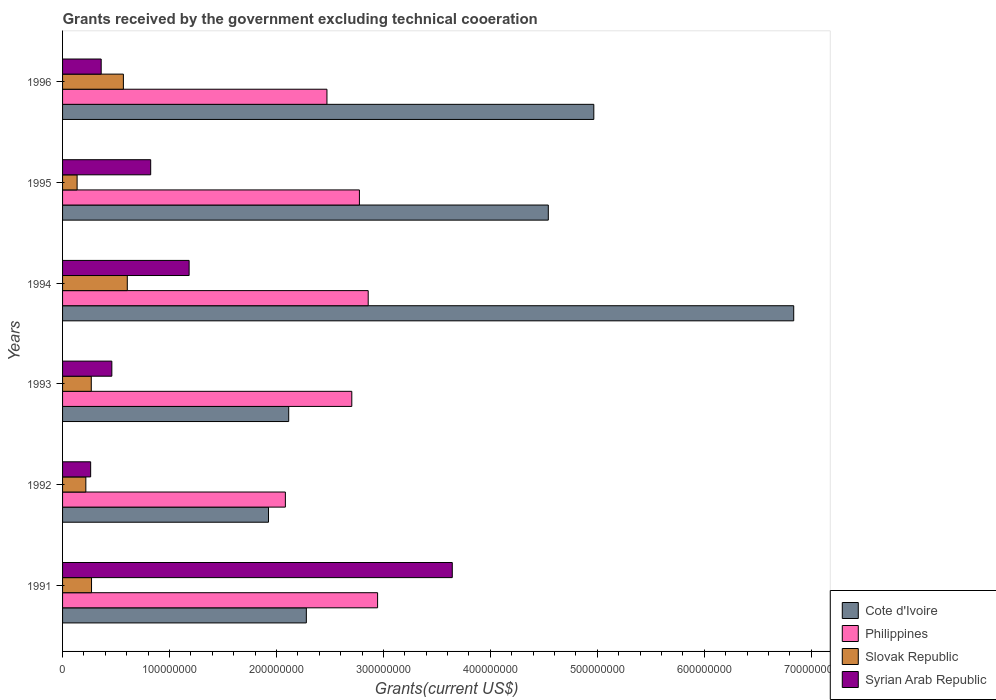How many different coloured bars are there?
Make the answer very short. 4. Are the number of bars per tick equal to the number of legend labels?
Offer a very short reply. Yes. Are the number of bars on each tick of the Y-axis equal?
Provide a succinct answer. Yes. How many bars are there on the 3rd tick from the bottom?
Your response must be concise. 4. What is the total grants received by the government in Syrian Arab Republic in 1992?
Provide a short and direct response. 2.63e+07. Across all years, what is the maximum total grants received by the government in Philippines?
Offer a terse response. 2.95e+08. Across all years, what is the minimum total grants received by the government in Slovak Republic?
Your answer should be very brief. 1.36e+07. In which year was the total grants received by the government in Philippines minimum?
Give a very brief answer. 1992. What is the total total grants received by the government in Syrian Arab Republic in the graph?
Offer a terse response. 6.74e+08. What is the difference between the total grants received by the government in Philippines in 1994 and that in 1996?
Your answer should be compact. 3.86e+07. What is the difference between the total grants received by the government in Cote d'Ivoire in 1994 and the total grants received by the government in Philippines in 1991?
Offer a very short reply. 3.89e+08. What is the average total grants received by the government in Cote d'Ivoire per year?
Keep it short and to the point. 3.78e+08. In the year 1991, what is the difference between the total grants received by the government in Cote d'Ivoire and total grants received by the government in Slovak Republic?
Make the answer very short. 2.01e+08. What is the ratio of the total grants received by the government in Philippines in 1993 to that in 1996?
Your answer should be compact. 1.09. What is the difference between the highest and the second highest total grants received by the government in Syrian Arab Republic?
Your answer should be compact. 2.46e+08. What is the difference between the highest and the lowest total grants received by the government in Syrian Arab Republic?
Keep it short and to the point. 3.38e+08. In how many years, is the total grants received by the government in Syrian Arab Republic greater than the average total grants received by the government in Syrian Arab Republic taken over all years?
Offer a very short reply. 2. What does the 3rd bar from the top in 1995 represents?
Make the answer very short. Philippines. What does the 2nd bar from the bottom in 1996 represents?
Make the answer very short. Philippines. How many bars are there?
Ensure brevity in your answer.  24. Does the graph contain grids?
Ensure brevity in your answer.  No. Where does the legend appear in the graph?
Provide a short and direct response. Bottom right. What is the title of the graph?
Offer a terse response. Grants received by the government excluding technical cooeration. What is the label or title of the X-axis?
Your answer should be compact. Grants(current US$). What is the Grants(current US$) of Cote d'Ivoire in 1991?
Provide a short and direct response. 2.28e+08. What is the Grants(current US$) in Philippines in 1991?
Your answer should be compact. 2.95e+08. What is the Grants(current US$) of Slovak Republic in 1991?
Make the answer very short. 2.71e+07. What is the Grants(current US$) in Syrian Arab Republic in 1991?
Keep it short and to the point. 3.64e+08. What is the Grants(current US$) in Cote d'Ivoire in 1992?
Make the answer very short. 1.93e+08. What is the Grants(current US$) of Philippines in 1992?
Offer a very short reply. 2.08e+08. What is the Grants(current US$) of Slovak Republic in 1992?
Offer a terse response. 2.18e+07. What is the Grants(current US$) in Syrian Arab Republic in 1992?
Offer a very short reply. 2.63e+07. What is the Grants(current US$) in Cote d'Ivoire in 1993?
Make the answer very short. 2.11e+08. What is the Grants(current US$) of Philippines in 1993?
Provide a short and direct response. 2.70e+08. What is the Grants(current US$) of Slovak Republic in 1993?
Offer a very short reply. 2.68e+07. What is the Grants(current US$) of Syrian Arab Republic in 1993?
Give a very brief answer. 4.61e+07. What is the Grants(current US$) of Cote d'Ivoire in 1994?
Offer a terse response. 6.84e+08. What is the Grants(current US$) of Philippines in 1994?
Provide a short and direct response. 2.86e+08. What is the Grants(current US$) in Slovak Republic in 1994?
Keep it short and to the point. 6.05e+07. What is the Grants(current US$) of Syrian Arab Republic in 1994?
Offer a terse response. 1.18e+08. What is the Grants(current US$) of Cote d'Ivoire in 1995?
Give a very brief answer. 4.54e+08. What is the Grants(current US$) in Philippines in 1995?
Offer a very short reply. 2.78e+08. What is the Grants(current US$) of Slovak Republic in 1995?
Provide a succinct answer. 1.36e+07. What is the Grants(current US$) of Syrian Arab Republic in 1995?
Keep it short and to the point. 8.24e+07. What is the Grants(current US$) of Cote d'Ivoire in 1996?
Ensure brevity in your answer.  4.97e+08. What is the Grants(current US$) of Philippines in 1996?
Provide a succinct answer. 2.47e+08. What is the Grants(current US$) in Slovak Republic in 1996?
Keep it short and to the point. 5.69e+07. What is the Grants(current US$) in Syrian Arab Republic in 1996?
Offer a very short reply. 3.61e+07. Across all years, what is the maximum Grants(current US$) in Cote d'Ivoire?
Your response must be concise. 6.84e+08. Across all years, what is the maximum Grants(current US$) of Philippines?
Make the answer very short. 2.95e+08. Across all years, what is the maximum Grants(current US$) of Slovak Republic?
Your answer should be very brief. 6.05e+07. Across all years, what is the maximum Grants(current US$) of Syrian Arab Republic?
Your response must be concise. 3.64e+08. Across all years, what is the minimum Grants(current US$) of Cote d'Ivoire?
Ensure brevity in your answer.  1.93e+08. Across all years, what is the minimum Grants(current US$) of Philippines?
Ensure brevity in your answer.  2.08e+08. Across all years, what is the minimum Grants(current US$) of Slovak Republic?
Give a very brief answer. 1.36e+07. Across all years, what is the minimum Grants(current US$) of Syrian Arab Republic?
Provide a short and direct response. 2.63e+07. What is the total Grants(current US$) in Cote d'Ivoire in the graph?
Your response must be concise. 2.27e+09. What is the total Grants(current US$) of Philippines in the graph?
Provide a succinct answer. 1.58e+09. What is the total Grants(current US$) of Slovak Republic in the graph?
Provide a succinct answer. 2.07e+08. What is the total Grants(current US$) in Syrian Arab Republic in the graph?
Give a very brief answer. 6.74e+08. What is the difference between the Grants(current US$) in Cote d'Ivoire in 1991 and that in 1992?
Your response must be concise. 3.54e+07. What is the difference between the Grants(current US$) in Philippines in 1991 and that in 1992?
Keep it short and to the point. 8.62e+07. What is the difference between the Grants(current US$) in Slovak Republic in 1991 and that in 1992?
Provide a succinct answer. 5.33e+06. What is the difference between the Grants(current US$) of Syrian Arab Republic in 1991 and that in 1992?
Provide a succinct answer. 3.38e+08. What is the difference between the Grants(current US$) of Cote d'Ivoire in 1991 and that in 1993?
Offer a terse response. 1.65e+07. What is the difference between the Grants(current US$) of Philippines in 1991 and that in 1993?
Provide a short and direct response. 2.41e+07. What is the difference between the Grants(current US$) of Slovak Republic in 1991 and that in 1993?
Offer a very short reply. 2.40e+05. What is the difference between the Grants(current US$) in Syrian Arab Republic in 1991 and that in 1993?
Make the answer very short. 3.18e+08. What is the difference between the Grants(current US$) in Cote d'Ivoire in 1991 and that in 1994?
Keep it short and to the point. -4.56e+08. What is the difference between the Grants(current US$) in Philippines in 1991 and that in 1994?
Your response must be concise. 8.77e+06. What is the difference between the Grants(current US$) in Slovak Republic in 1991 and that in 1994?
Ensure brevity in your answer.  -3.34e+07. What is the difference between the Grants(current US$) in Syrian Arab Republic in 1991 and that in 1994?
Make the answer very short. 2.46e+08. What is the difference between the Grants(current US$) of Cote d'Ivoire in 1991 and that in 1995?
Keep it short and to the point. -2.26e+08. What is the difference between the Grants(current US$) in Philippines in 1991 and that in 1995?
Provide a succinct answer. 1.70e+07. What is the difference between the Grants(current US$) in Slovak Republic in 1991 and that in 1995?
Offer a terse response. 1.35e+07. What is the difference between the Grants(current US$) in Syrian Arab Republic in 1991 and that in 1995?
Give a very brief answer. 2.82e+08. What is the difference between the Grants(current US$) in Cote d'Ivoire in 1991 and that in 1996?
Your answer should be compact. -2.69e+08. What is the difference between the Grants(current US$) of Philippines in 1991 and that in 1996?
Provide a short and direct response. 4.74e+07. What is the difference between the Grants(current US$) of Slovak Republic in 1991 and that in 1996?
Your answer should be very brief. -2.98e+07. What is the difference between the Grants(current US$) in Syrian Arab Republic in 1991 and that in 1996?
Ensure brevity in your answer.  3.28e+08. What is the difference between the Grants(current US$) of Cote d'Ivoire in 1992 and that in 1993?
Offer a terse response. -1.89e+07. What is the difference between the Grants(current US$) of Philippines in 1992 and that in 1993?
Provide a short and direct response. -6.21e+07. What is the difference between the Grants(current US$) of Slovak Republic in 1992 and that in 1993?
Your answer should be very brief. -5.09e+06. What is the difference between the Grants(current US$) of Syrian Arab Republic in 1992 and that in 1993?
Your answer should be compact. -1.98e+07. What is the difference between the Grants(current US$) of Cote d'Ivoire in 1992 and that in 1994?
Ensure brevity in your answer.  -4.91e+08. What is the difference between the Grants(current US$) in Philippines in 1992 and that in 1994?
Offer a terse response. -7.74e+07. What is the difference between the Grants(current US$) of Slovak Republic in 1992 and that in 1994?
Offer a very short reply. -3.88e+07. What is the difference between the Grants(current US$) in Syrian Arab Republic in 1992 and that in 1994?
Keep it short and to the point. -9.21e+07. What is the difference between the Grants(current US$) of Cote d'Ivoire in 1992 and that in 1995?
Provide a short and direct response. -2.62e+08. What is the difference between the Grants(current US$) in Philippines in 1992 and that in 1995?
Provide a succinct answer. -6.92e+07. What is the difference between the Grants(current US$) of Slovak Republic in 1992 and that in 1995?
Your answer should be very brief. 8.16e+06. What is the difference between the Grants(current US$) in Syrian Arab Republic in 1992 and that in 1995?
Give a very brief answer. -5.61e+07. What is the difference between the Grants(current US$) of Cote d'Ivoire in 1992 and that in 1996?
Make the answer very short. -3.04e+08. What is the difference between the Grants(current US$) in Philippines in 1992 and that in 1996?
Your answer should be very brief. -3.89e+07. What is the difference between the Grants(current US$) of Slovak Republic in 1992 and that in 1996?
Offer a very short reply. -3.51e+07. What is the difference between the Grants(current US$) in Syrian Arab Republic in 1992 and that in 1996?
Give a very brief answer. -9.85e+06. What is the difference between the Grants(current US$) of Cote d'Ivoire in 1993 and that in 1994?
Your response must be concise. -4.72e+08. What is the difference between the Grants(current US$) of Philippines in 1993 and that in 1994?
Offer a terse response. -1.54e+07. What is the difference between the Grants(current US$) in Slovak Republic in 1993 and that in 1994?
Keep it short and to the point. -3.37e+07. What is the difference between the Grants(current US$) of Syrian Arab Republic in 1993 and that in 1994?
Keep it short and to the point. -7.23e+07. What is the difference between the Grants(current US$) of Cote d'Ivoire in 1993 and that in 1995?
Keep it short and to the point. -2.43e+08. What is the difference between the Grants(current US$) in Philippines in 1993 and that in 1995?
Offer a terse response. -7.13e+06. What is the difference between the Grants(current US$) in Slovak Republic in 1993 and that in 1995?
Your answer should be compact. 1.32e+07. What is the difference between the Grants(current US$) of Syrian Arab Republic in 1993 and that in 1995?
Give a very brief answer. -3.63e+07. What is the difference between the Grants(current US$) in Cote d'Ivoire in 1993 and that in 1996?
Your answer should be very brief. -2.85e+08. What is the difference between the Grants(current US$) in Philippines in 1993 and that in 1996?
Offer a very short reply. 2.32e+07. What is the difference between the Grants(current US$) in Slovak Republic in 1993 and that in 1996?
Keep it short and to the point. -3.00e+07. What is the difference between the Grants(current US$) of Syrian Arab Republic in 1993 and that in 1996?
Provide a short and direct response. 9.96e+06. What is the difference between the Grants(current US$) of Cote d'Ivoire in 1994 and that in 1995?
Give a very brief answer. 2.29e+08. What is the difference between the Grants(current US$) in Philippines in 1994 and that in 1995?
Keep it short and to the point. 8.22e+06. What is the difference between the Grants(current US$) of Slovak Republic in 1994 and that in 1995?
Your answer should be very brief. 4.69e+07. What is the difference between the Grants(current US$) of Syrian Arab Republic in 1994 and that in 1995?
Provide a succinct answer. 3.59e+07. What is the difference between the Grants(current US$) of Cote d'Ivoire in 1994 and that in 1996?
Offer a very short reply. 1.87e+08. What is the difference between the Grants(current US$) in Philippines in 1994 and that in 1996?
Make the answer very short. 3.86e+07. What is the difference between the Grants(current US$) of Slovak Republic in 1994 and that in 1996?
Provide a short and direct response. 3.66e+06. What is the difference between the Grants(current US$) in Syrian Arab Republic in 1994 and that in 1996?
Keep it short and to the point. 8.22e+07. What is the difference between the Grants(current US$) in Cote d'Ivoire in 1995 and that in 1996?
Your answer should be compact. -4.26e+07. What is the difference between the Grants(current US$) of Philippines in 1995 and that in 1996?
Give a very brief answer. 3.04e+07. What is the difference between the Grants(current US$) in Slovak Republic in 1995 and that in 1996?
Your answer should be compact. -4.33e+07. What is the difference between the Grants(current US$) in Syrian Arab Republic in 1995 and that in 1996?
Your answer should be compact. 4.63e+07. What is the difference between the Grants(current US$) in Cote d'Ivoire in 1991 and the Grants(current US$) in Philippines in 1992?
Offer a terse response. 1.96e+07. What is the difference between the Grants(current US$) in Cote d'Ivoire in 1991 and the Grants(current US$) in Slovak Republic in 1992?
Your response must be concise. 2.06e+08. What is the difference between the Grants(current US$) of Cote d'Ivoire in 1991 and the Grants(current US$) of Syrian Arab Republic in 1992?
Ensure brevity in your answer.  2.02e+08. What is the difference between the Grants(current US$) of Philippines in 1991 and the Grants(current US$) of Slovak Republic in 1992?
Your answer should be very brief. 2.73e+08. What is the difference between the Grants(current US$) of Philippines in 1991 and the Grants(current US$) of Syrian Arab Republic in 1992?
Your answer should be compact. 2.68e+08. What is the difference between the Grants(current US$) of Slovak Republic in 1991 and the Grants(current US$) of Syrian Arab Republic in 1992?
Offer a terse response. 8.20e+05. What is the difference between the Grants(current US$) in Cote d'Ivoire in 1991 and the Grants(current US$) in Philippines in 1993?
Give a very brief answer. -4.25e+07. What is the difference between the Grants(current US$) of Cote d'Ivoire in 1991 and the Grants(current US$) of Slovak Republic in 1993?
Offer a terse response. 2.01e+08. What is the difference between the Grants(current US$) of Cote d'Ivoire in 1991 and the Grants(current US$) of Syrian Arab Republic in 1993?
Provide a short and direct response. 1.82e+08. What is the difference between the Grants(current US$) of Philippines in 1991 and the Grants(current US$) of Slovak Republic in 1993?
Your answer should be very brief. 2.68e+08. What is the difference between the Grants(current US$) of Philippines in 1991 and the Grants(current US$) of Syrian Arab Republic in 1993?
Make the answer very short. 2.48e+08. What is the difference between the Grants(current US$) of Slovak Republic in 1991 and the Grants(current US$) of Syrian Arab Republic in 1993?
Your answer should be very brief. -1.90e+07. What is the difference between the Grants(current US$) in Cote d'Ivoire in 1991 and the Grants(current US$) in Philippines in 1994?
Offer a terse response. -5.78e+07. What is the difference between the Grants(current US$) of Cote d'Ivoire in 1991 and the Grants(current US$) of Slovak Republic in 1994?
Your response must be concise. 1.67e+08. What is the difference between the Grants(current US$) of Cote d'Ivoire in 1991 and the Grants(current US$) of Syrian Arab Republic in 1994?
Keep it short and to the point. 1.10e+08. What is the difference between the Grants(current US$) of Philippines in 1991 and the Grants(current US$) of Slovak Republic in 1994?
Offer a terse response. 2.34e+08. What is the difference between the Grants(current US$) in Philippines in 1991 and the Grants(current US$) in Syrian Arab Republic in 1994?
Offer a very short reply. 1.76e+08. What is the difference between the Grants(current US$) in Slovak Republic in 1991 and the Grants(current US$) in Syrian Arab Republic in 1994?
Provide a succinct answer. -9.12e+07. What is the difference between the Grants(current US$) of Cote d'Ivoire in 1991 and the Grants(current US$) of Philippines in 1995?
Give a very brief answer. -4.96e+07. What is the difference between the Grants(current US$) of Cote d'Ivoire in 1991 and the Grants(current US$) of Slovak Republic in 1995?
Make the answer very short. 2.14e+08. What is the difference between the Grants(current US$) in Cote d'Ivoire in 1991 and the Grants(current US$) in Syrian Arab Republic in 1995?
Provide a succinct answer. 1.46e+08. What is the difference between the Grants(current US$) of Philippines in 1991 and the Grants(current US$) of Slovak Republic in 1995?
Offer a terse response. 2.81e+08. What is the difference between the Grants(current US$) of Philippines in 1991 and the Grants(current US$) of Syrian Arab Republic in 1995?
Offer a terse response. 2.12e+08. What is the difference between the Grants(current US$) in Slovak Republic in 1991 and the Grants(current US$) in Syrian Arab Republic in 1995?
Keep it short and to the point. -5.53e+07. What is the difference between the Grants(current US$) in Cote d'Ivoire in 1991 and the Grants(current US$) in Philippines in 1996?
Offer a terse response. -1.93e+07. What is the difference between the Grants(current US$) in Cote d'Ivoire in 1991 and the Grants(current US$) in Slovak Republic in 1996?
Offer a terse response. 1.71e+08. What is the difference between the Grants(current US$) in Cote d'Ivoire in 1991 and the Grants(current US$) in Syrian Arab Republic in 1996?
Your answer should be very brief. 1.92e+08. What is the difference between the Grants(current US$) of Philippines in 1991 and the Grants(current US$) of Slovak Republic in 1996?
Ensure brevity in your answer.  2.38e+08. What is the difference between the Grants(current US$) of Philippines in 1991 and the Grants(current US$) of Syrian Arab Republic in 1996?
Offer a terse response. 2.58e+08. What is the difference between the Grants(current US$) in Slovak Republic in 1991 and the Grants(current US$) in Syrian Arab Republic in 1996?
Make the answer very short. -9.03e+06. What is the difference between the Grants(current US$) of Cote d'Ivoire in 1992 and the Grants(current US$) of Philippines in 1993?
Make the answer very short. -7.79e+07. What is the difference between the Grants(current US$) of Cote d'Ivoire in 1992 and the Grants(current US$) of Slovak Republic in 1993?
Keep it short and to the point. 1.66e+08. What is the difference between the Grants(current US$) of Cote d'Ivoire in 1992 and the Grants(current US$) of Syrian Arab Republic in 1993?
Ensure brevity in your answer.  1.46e+08. What is the difference between the Grants(current US$) in Philippines in 1992 and the Grants(current US$) in Slovak Republic in 1993?
Provide a short and direct response. 1.82e+08. What is the difference between the Grants(current US$) of Philippines in 1992 and the Grants(current US$) of Syrian Arab Republic in 1993?
Your response must be concise. 1.62e+08. What is the difference between the Grants(current US$) in Slovak Republic in 1992 and the Grants(current US$) in Syrian Arab Republic in 1993?
Keep it short and to the point. -2.43e+07. What is the difference between the Grants(current US$) in Cote d'Ivoire in 1992 and the Grants(current US$) in Philippines in 1994?
Ensure brevity in your answer.  -9.32e+07. What is the difference between the Grants(current US$) in Cote d'Ivoire in 1992 and the Grants(current US$) in Slovak Republic in 1994?
Keep it short and to the point. 1.32e+08. What is the difference between the Grants(current US$) of Cote d'Ivoire in 1992 and the Grants(current US$) of Syrian Arab Republic in 1994?
Provide a succinct answer. 7.42e+07. What is the difference between the Grants(current US$) in Philippines in 1992 and the Grants(current US$) in Slovak Republic in 1994?
Offer a very short reply. 1.48e+08. What is the difference between the Grants(current US$) of Philippines in 1992 and the Grants(current US$) of Syrian Arab Republic in 1994?
Give a very brief answer. 9.00e+07. What is the difference between the Grants(current US$) in Slovak Republic in 1992 and the Grants(current US$) in Syrian Arab Republic in 1994?
Your answer should be very brief. -9.66e+07. What is the difference between the Grants(current US$) of Cote d'Ivoire in 1992 and the Grants(current US$) of Philippines in 1995?
Give a very brief answer. -8.50e+07. What is the difference between the Grants(current US$) in Cote d'Ivoire in 1992 and the Grants(current US$) in Slovak Republic in 1995?
Offer a terse response. 1.79e+08. What is the difference between the Grants(current US$) in Cote d'Ivoire in 1992 and the Grants(current US$) in Syrian Arab Republic in 1995?
Your answer should be compact. 1.10e+08. What is the difference between the Grants(current US$) in Philippines in 1992 and the Grants(current US$) in Slovak Republic in 1995?
Offer a terse response. 1.95e+08. What is the difference between the Grants(current US$) of Philippines in 1992 and the Grants(current US$) of Syrian Arab Republic in 1995?
Offer a very short reply. 1.26e+08. What is the difference between the Grants(current US$) of Slovak Republic in 1992 and the Grants(current US$) of Syrian Arab Republic in 1995?
Your answer should be very brief. -6.06e+07. What is the difference between the Grants(current US$) of Cote d'Ivoire in 1992 and the Grants(current US$) of Philippines in 1996?
Offer a very short reply. -5.47e+07. What is the difference between the Grants(current US$) of Cote d'Ivoire in 1992 and the Grants(current US$) of Slovak Republic in 1996?
Offer a terse response. 1.36e+08. What is the difference between the Grants(current US$) of Cote d'Ivoire in 1992 and the Grants(current US$) of Syrian Arab Republic in 1996?
Your answer should be very brief. 1.56e+08. What is the difference between the Grants(current US$) of Philippines in 1992 and the Grants(current US$) of Slovak Republic in 1996?
Provide a short and direct response. 1.51e+08. What is the difference between the Grants(current US$) of Philippines in 1992 and the Grants(current US$) of Syrian Arab Republic in 1996?
Give a very brief answer. 1.72e+08. What is the difference between the Grants(current US$) in Slovak Republic in 1992 and the Grants(current US$) in Syrian Arab Republic in 1996?
Make the answer very short. -1.44e+07. What is the difference between the Grants(current US$) of Cote d'Ivoire in 1993 and the Grants(current US$) of Philippines in 1994?
Keep it short and to the point. -7.44e+07. What is the difference between the Grants(current US$) in Cote d'Ivoire in 1993 and the Grants(current US$) in Slovak Republic in 1994?
Your response must be concise. 1.51e+08. What is the difference between the Grants(current US$) in Cote d'Ivoire in 1993 and the Grants(current US$) in Syrian Arab Republic in 1994?
Make the answer very short. 9.31e+07. What is the difference between the Grants(current US$) in Philippines in 1993 and the Grants(current US$) in Slovak Republic in 1994?
Ensure brevity in your answer.  2.10e+08. What is the difference between the Grants(current US$) of Philippines in 1993 and the Grants(current US$) of Syrian Arab Republic in 1994?
Keep it short and to the point. 1.52e+08. What is the difference between the Grants(current US$) in Slovak Republic in 1993 and the Grants(current US$) in Syrian Arab Republic in 1994?
Keep it short and to the point. -9.15e+07. What is the difference between the Grants(current US$) in Cote d'Ivoire in 1993 and the Grants(current US$) in Philippines in 1995?
Ensure brevity in your answer.  -6.61e+07. What is the difference between the Grants(current US$) in Cote d'Ivoire in 1993 and the Grants(current US$) in Slovak Republic in 1995?
Provide a succinct answer. 1.98e+08. What is the difference between the Grants(current US$) in Cote d'Ivoire in 1993 and the Grants(current US$) in Syrian Arab Republic in 1995?
Your answer should be compact. 1.29e+08. What is the difference between the Grants(current US$) of Philippines in 1993 and the Grants(current US$) of Slovak Republic in 1995?
Provide a short and direct response. 2.57e+08. What is the difference between the Grants(current US$) in Philippines in 1993 and the Grants(current US$) in Syrian Arab Republic in 1995?
Offer a terse response. 1.88e+08. What is the difference between the Grants(current US$) of Slovak Republic in 1993 and the Grants(current US$) of Syrian Arab Republic in 1995?
Provide a succinct answer. -5.56e+07. What is the difference between the Grants(current US$) in Cote d'Ivoire in 1993 and the Grants(current US$) in Philippines in 1996?
Provide a succinct answer. -3.58e+07. What is the difference between the Grants(current US$) of Cote d'Ivoire in 1993 and the Grants(current US$) of Slovak Republic in 1996?
Your answer should be very brief. 1.55e+08. What is the difference between the Grants(current US$) in Cote d'Ivoire in 1993 and the Grants(current US$) in Syrian Arab Republic in 1996?
Your answer should be compact. 1.75e+08. What is the difference between the Grants(current US$) of Philippines in 1993 and the Grants(current US$) of Slovak Republic in 1996?
Offer a very short reply. 2.14e+08. What is the difference between the Grants(current US$) in Philippines in 1993 and the Grants(current US$) in Syrian Arab Republic in 1996?
Your answer should be very brief. 2.34e+08. What is the difference between the Grants(current US$) in Slovak Republic in 1993 and the Grants(current US$) in Syrian Arab Republic in 1996?
Offer a terse response. -9.27e+06. What is the difference between the Grants(current US$) of Cote d'Ivoire in 1994 and the Grants(current US$) of Philippines in 1995?
Keep it short and to the point. 4.06e+08. What is the difference between the Grants(current US$) in Cote d'Ivoire in 1994 and the Grants(current US$) in Slovak Republic in 1995?
Your answer should be compact. 6.70e+08. What is the difference between the Grants(current US$) in Cote d'Ivoire in 1994 and the Grants(current US$) in Syrian Arab Republic in 1995?
Give a very brief answer. 6.01e+08. What is the difference between the Grants(current US$) of Philippines in 1994 and the Grants(current US$) of Slovak Republic in 1995?
Make the answer very short. 2.72e+08. What is the difference between the Grants(current US$) of Philippines in 1994 and the Grants(current US$) of Syrian Arab Republic in 1995?
Make the answer very short. 2.03e+08. What is the difference between the Grants(current US$) of Slovak Republic in 1994 and the Grants(current US$) of Syrian Arab Republic in 1995?
Your answer should be compact. -2.19e+07. What is the difference between the Grants(current US$) in Cote d'Ivoire in 1994 and the Grants(current US$) in Philippines in 1996?
Provide a short and direct response. 4.36e+08. What is the difference between the Grants(current US$) of Cote d'Ivoire in 1994 and the Grants(current US$) of Slovak Republic in 1996?
Offer a very short reply. 6.27e+08. What is the difference between the Grants(current US$) in Cote d'Ivoire in 1994 and the Grants(current US$) in Syrian Arab Republic in 1996?
Your answer should be very brief. 6.48e+08. What is the difference between the Grants(current US$) in Philippines in 1994 and the Grants(current US$) in Slovak Republic in 1996?
Keep it short and to the point. 2.29e+08. What is the difference between the Grants(current US$) in Philippines in 1994 and the Grants(current US$) in Syrian Arab Republic in 1996?
Provide a succinct answer. 2.50e+08. What is the difference between the Grants(current US$) of Slovak Republic in 1994 and the Grants(current US$) of Syrian Arab Republic in 1996?
Offer a terse response. 2.44e+07. What is the difference between the Grants(current US$) in Cote d'Ivoire in 1995 and the Grants(current US$) in Philippines in 1996?
Offer a terse response. 2.07e+08. What is the difference between the Grants(current US$) of Cote d'Ivoire in 1995 and the Grants(current US$) of Slovak Republic in 1996?
Make the answer very short. 3.97e+08. What is the difference between the Grants(current US$) of Cote d'Ivoire in 1995 and the Grants(current US$) of Syrian Arab Republic in 1996?
Make the answer very short. 4.18e+08. What is the difference between the Grants(current US$) of Philippines in 1995 and the Grants(current US$) of Slovak Republic in 1996?
Your answer should be very brief. 2.21e+08. What is the difference between the Grants(current US$) in Philippines in 1995 and the Grants(current US$) in Syrian Arab Republic in 1996?
Make the answer very short. 2.41e+08. What is the difference between the Grants(current US$) of Slovak Republic in 1995 and the Grants(current US$) of Syrian Arab Republic in 1996?
Give a very brief answer. -2.25e+07. What is the average Grants(current US$) in Cote d'Ivoire per year?
Keep it short and to the point. 3.78e+08. What is the average Grants(current US$) of Philippines per year?
Ensure brevity in your answer.  2.64e+08. What is the average Grants(current US$) in Slovak Republic per year?
Your answer should be very brief. 3.44e+07. What is the average Grants(current US$) in Syrian Arab Republic per year?
Keep it short and to the point. 1.12e+08. In the year 1991, what is the difference between the Grants(current US$) in Cote d'Ivoire and Grants(current US$) in Philippines?
Your response must be concise. -6.66e+07. In the year 1991, what is the difference between the Grants(current US$) of Cote d'Ivoire and Grants(current US$) of Slovak Republic?
Keep it short and to the point. 2.01e+08. In the year 1991, what is the difference between the Grants(current US$) in Cote d'Ivoire and Grants(current US$) in Syrian Arab Republic?
Provide a short and direct response. -1.36e+08. In the year 1991, what is the difference between the Grants(current US$) of Philippines and Grants(current US$) of Slovak Republic?
Your response must be concise. 2.67e+08. In the year 1991, what is the difference between the Grants(current US$) of Philippines and Grants(current US$) of Syrian Arab Republic?
Keep it short and to the point. -6.98e+07. In the year 1991, what is the difference between the Grants(current US$) in Slovak Republic and Grants(current US$) in Syrian Arab Republic?
Make the answer very short. -3.37e+08. In the year 1992, what is the difference between the Grants(current US$) of Cote d'Ivoire and Grants(current US$) of Philippines?
Offer a very short reply. -1.58e+07. In the year 1992, what is the difference between the Grants(current US$) in Cote d'Ivoire and Grants(current US$) in Slovak Republic?
Offer a very short reply. 1.71e+08. In the year 1992, what is the difference between the Grants(current US$) in Cote d'Ivoire and Grants(current US$) in Syrian Arab Republic?
Ensure brevity in your answer.  1.66e+08. In the year 1992, what is the difference between the Grants(current US$) of Philippines and Grants(current US$) of Slovak Republic?
Give a very brief answer. 1.87e+08. In the year 1992, what is the difference between the Grants(current US$) of Philippines and Grants(current US$) of Syrian Arab Republic?
Your answer should be compact. 1.82e+08. In the year 1992, what is the difference between the Grants(current US$) in Slovak Republic and Grants(current US$) in Syrian Arab Republic?
Your response must be concise. -4.51e+06. In the year 1993, what is the difference between the Grants(current US$) in Cote d'Ivoire and Grants(current US$) in Philippines?
Keep it short and to the point. -5.90e+07. In the year 1993, what is the difference between the Grants(current US$) in Cote d'Ivoire and Grants(current US$) in Slovak Republic?
Offer a terse response. 1.85e+08. In the year 1993, what is the difference between the Grants(current US$) in Cote d'Ivoire and Grants(current US$) in Syrian Arab Republic?
Provide a short and direct response. 1.65e+08. In the year 1993, what is the difference between the Grants(current US$) in Philippines and Grants(current US$) in Slovak Republic?
Offer a very short reply. 2.44e+08. In the year 1993, what is the difference between the Grants(current US$) in Philippines and Grants(current US$) in Syrian Arab Republic?
Keep it short and to the point. 2.24e+08. In the year 1993, what is the difference between the Grants(current US$) of Slovak Republic and Grants(current US$) of Syrian Arab Republic?
Keep it short and to the point. -1.92e+07. In the year 1994, what is the difference between the Grants(current US$) in Cote d'Ivoire and Grants(current US$) in Philippines?
Provide a short and direct response. 3.98e+08. In the year 1994, what is the difference between the Grants(current US$) of Cote d'Ivoire and Grants(current US$) of Slovak Republic?
Provide a succinct answer. 6.23e+08. In the year 1994, what is the difference between the Grants(current US$) in Cote d'Ivoire and Grants(current US$) in Syrian Arab Republic?
Your response must be concise. 5.65e+08. In the year 1994, what is the difference between the Grants(current US$) in Philippines and Grants(current US$) in Slovak Republic?
Your answer should be very brief. 2.25e+08. In the year 1994, what is the difference between the Grants(current US$) of Philippines and Grants(current US$) of Syrian Arab Republic?
Ensure brevity in your answer.  1.67e+08. In the year 1994, what is the difference between the Grants(current US$) of Slovak Republic and Grants(current US$) of Syrian Arab Republic?
Your response must be concise. -5.78e+07. In the year 1995, what is the difference between the Grants(current US$) of Cote d'Ivoire and Grants(current US$) of Philippines?
Give a very brief answer. 1.77e+08. In the year 1995, what is the difference between the Grants(current US$) in Cote d'Ivoire and Grants(current US$) in Slovak Republic?
Provide a short and direct response. 4.41e+08. In the year 1995, what is the difference between the Grants(current US$) of Cote d'Ivoire and Grants(current US$) of Syrian Arab Republic?
Your answer should be compact. 3.72e+08. In the year 1995, what is the difference between the Grants(current US$) in Philippines and Grants(current US$) in Slovak Republic?
Ensure brevity in your answer.  2.64e+08. In the year 1995, what is the difference between the Grants(current US$) of Philippines and Grants(current US$) of Syrian Arab Republic?
Ensure brevity in your answer.  1.95e+08. In the year 1995, what is the difference between the Grants(current US$) in Slovak Republic and Grants(current US$) in Syrian Arab Republic?
Provide a succinct answer. -6.88e+07. In the year 1996, what is the difference between the Grants(current US$) of Cote d'Ivoire and Grants(current US$) of Philippines?
Provide a succinct answer. 2.50e+08. In the year 1996, what is the difference between the Grants(current US$) in Cote d'Ivoire and Grants(current US$) in Slovak Republic?
Provide a succinct answer. 4.40e+08. In the year 1996, what is the difference between the Grants(current US$) of Cote d'Ivoire and Grants(current US$) of Syrian Arab Republic?
Offer a very short reply. 4.61e+08. In the year 1996, what is the difference between the Grants(current US$) in Philippines and Grants(current US$) in Slovak Republic?
Make the answer very short. 1.90e+08. In the year 1996, what is the difference between the Grants(current US$) in Philippines and Grants(current US$) in Syrian Arab Republic?
Provide a short and direct response. 2.11e+08. In the year 1996, what is the difference between the Grants(current US$) in Slovak Republic and Grants(current US$) in Syrian Arab Republic?
Give a very brief answer. 2.08e+07. What is the ratio of the Grants(current US$) of Cote d'Ivoire in 1991 to that in 1992?
Keep it short and to the point. 1.18. What is the ratio of the Grants(current US$) of Philippines in 1991 to that in 1992?
Give a very brief answer. 1.41. What is the ratio of the Grants(current US$) of Slovak Republic in 1991 to that in 1992?
Your response must be concise. 1.24. What is the ratio of the Grants(current US$) in Syrian Arab Republic in 1991 to that in 1992?
Offer a very short reply. 13.87. What is the ratio of the Grants(current US$) in Cote d'Ivoire in 1991 to that in 1993?
Make the answer very short. 1.08. What is the ratio of the Grants(current US$) of Philippines in 1991 to that in 1993?
Your answer should be very brief. 1.09. What is the ratio of the Grants(current US$) in Slovak Republic in 1991 to that in 1993?
Ensure brevity in your answer.  1.01. What is the ratio of the Grants(current US$) in Syrian Arab Republic in 1991 to that in 1993?
Your response must be concise. 7.91. What is the ratio of the Grants(current US$) in Cote d'Ivoire in 1991 to that in 1994?
Provide a succinct answer. 0.33. What is the ratio of the Grants(current US$) in Philippines in 1991 to that in 1994?
Keep it short and to the point. 1.03. What is the ratio of the Grants(current US$) of Slovak Republic in 1991 to that in 1994?
Your answer should be very brief. 0.45. What is the ratio of the Grants(current US$) of Syrian Arab Republic in 1991 to that in 1994?
Your response must be concise. 3.08. What is the ratio of the Grants(current US$) in Cote d'Ivoire in 1991 to that in 1995?
Give a very brief answer. 0.5. What is the ratio of the Grants(current US$) in Philippines in 1991 to that in 1995?
Offer a very short reply. 1.06. What is the ratio of the Grants(current US$) of Slovak Republic in 1991 to that in 1995?
Your answer should be compact. 1.99. What is the ratio of the Grants(current US$) in Syrian Arab Republic in 1991 to that in 1995?
Your response must be concise. 4.42. What is the ratio of the Grants(current US$) in Cote d'Ivoire in 1991 to that in 1996?
Make the answer very short. 0.46. What is the ratio of the Grants(current US$) of Philippines in 1991 to that in 1996?
Provide a succinct answer. 1.19. What is the ratio of the Grants(current US$) of Slovak Republic in 1991 to that in 1996?
Offer a terse response. 0.48. What is the ratio of the Grants(current US$) in Syrian Arab Republic in 1991 to that in 1996?
Give a very brief answer. 10.09. What is the ratio of the Grants(current US$) of Cote d'Ivoire in 1992 to that in 1993?
Provide a succinct answer. 0.91. What is the ratio of the Grants(current US$) of Philippines in 1992 to that in 1993?
Your answer should be very brief. 0.77. What is the ratio of the Grants(current US$) in Slovak Republic in 1992 to that in 1993?
Offer a very short reply. 0.81. What is the ratio of the Grants(current US$) in Syrian Arab Republic in 1992 to that in 1993?
Offer a terse response. 0.57. What is the ratio of the Grants(current US$) in Cote d'Ivoire in 1992 to that in 1994?
Offer a very short reply. 0.28. What is the ratio of the Grants(current US$) in Philippines in 1992 to that in 1994?
Offer a very short reply. 0.73. What is the ratio of the Grants(current US$) of Slovak Republic in 1992 to that in 1994?
Keep it short and to the point. 0.36. What is the ratio of the Grants(current US$) in Syrian Arab Republic in 1992 to that in 1994?
Offer a very short reply. 0.22. What is the ratio of the Grants(current US$) in Cote d'Ivoire in 1992 to that in 1995?
Provide a short and direct response. 0.42. What is the ratio of the Grants(current US$) in Philippines in 1992 to that in 1995?
Give a very brief answer. 0.75. What is the ratio of the Grants(current US$) in Slovak Republic in 1992 to that in 1995?
Your answer should be very brief. 1.6. What is the ratio of the Grants(current US$) of Syrian Arab Republic in 1992 to that in 1995?
Ensure brevity in your answer.  0.32. What is the ratio of the Grants(current US$) of Cote d'Ivoire in 1992 to that in 1996?
Give a very brief answer. 0.39. What is the ratio of the Grants(current US$) of Philippines in 1992 to that in 1996?
Make the answer very short. 0.84. What is the ratio of the Grants(current US$) of Slovak Republic in 1992 to that in 1996?
Make the answer very short. 0.38. What is the ratio of the Grants(current US$) of Syrian Arab Republic in 1992 to that in 1996?
Your answer should be compact. 0.73. What is the ratio of the Grants(current US$) in Cote d'Ivoire in 1993 to that in 1994?
Offer a terse response. 0.31. What is the ratio of the Grants(current US$) of Philippines in 1993 to that in 1994?
Your answer should be very brief. 0.95. What is the ratio of the Grants(current US$) of Slovak Republic in 1993 to that in 1994?
Offer a terse response. 0.44. What is the ratio of the Grants(current US$) of Syrian Arab Republic in 1993 to that in 1994?
Keep it short and to the point. 0.39. What is the ratio of the Grants(current US$) in Cote d'Ivoire in 1993 to that in 1995?
Your answer should be very brief. 0.47. What is the ratio of the Grants(current US$) of Philippines in 1993 to that in 1995?
Keep it short and to the point. 0.97. What is the ratio of the Grants(current US$) of Slovak Republic in 1993 to that in 1995?
Provide a short and direct response. 1.97. What is the ratio of the Grants(current US$) of Syrian Arab Republic in 1993 to that in 1995?
Offer a very short reply. 0.56. What is the ratio of the Grants(current US$) of Cote d'Ivoire in 1993 to that in 1996?
Your answer should be very brief. 0.43. What is the ratio of the Grants(current US$) in Philippines in 1993 to that in 1996?
Provide a succinct answer. 1.09. What is the ratio of the Grants(current US$) in Slovak Republic in 1993 to that in 1996?
Make the answer very short. 0.47. What is the ratio of the Grants(current US$) of Syrian Arab Republic in 1993 to that in 1996?
Your response must be concise. 1.28. What is the ratio of the Grants(current US$) in Cote d'Ivoire in 1994 to that in 1995?
Make the answer very short. 1.51. What is the ratio of the Grants(current US$) of Philippines in 1994 to that in 1995?
Your answer should be very brief. 1.03. What is the ratio of the Grants(current US$) in Slovak Republic in 1994 to that in 1995?
Provide a succinct answer. 4.45. What is the ratio of the Grants(current US$) in Syrian Arab Republic in 1994 to that in 1995?
Provide a succinct answer. 1.44. What is the ratio of the Grants(current US$) in Cote d'Ivoire in 1994 to that in 1996?
Provide a short and direct response. 1.38. What is the ratio of the Grants(current US$) in Philippines in 1994 to that in 1996?
Provide a short and direct response. 1.16. What is the ratio of the Grants(current US$) of Slovak Republic in 1994 to that in 1996?
Your answer should be compact. 1.06. What is the ratio of the Grants(current US$) in Syrian Arab Republic in 1994 to that in 1996?
Ensure brevity in your answer.  3.28. What is the ratio of the Grants(current US$) of Cote d'Ivoire in 1995 to that in 1996?
Ensure brevity in your answer.  0.91. What is the ratio of the Grants(current US$) in Philippines in 1995 to that in 1996?
Offer a very short reply. 1.12. What is the ratio of the Grants(current US$) in Slovak Republic in 1995 to that in 1996?
Give a very brief answer. 0.24. What is the ratio of the Grants(current US$) of Syrian Arab Republic in 1995 to that in 1996?
Keep it short and to the point. 2.28. What is the difference between the highest and the second highest Grants(current US$) in Cote d'Ivoire?
Provide a short and direct response. 1.87e+08. What is the difference between the highest and the second highest Grants(current US$) in Philippines?
Provide a succinct answer. 8.77e+06. What is the difference between the highest and the second highest Grants(current US$) of Slovak Republic?
Keep it short and to the point. 3.66e+06. What is the difference between the highest and the second highest Grants(current US$) of Syrian Arab Republic?
Your response must be concise. 2.46e+08. What is the difference between the highest and the lowest Grants(current US$) of Cote d'Ivoire?
Ensure brevity in your answer.  4.91e+08. What is the difference between the highest and the lowest Grants(current US$) of Philippines?
Your answer should be very brief. 8.62e+07. What is the difference between the highest and the lowest Grants(current US$) of Slovak Republic?
Offer a terse response. 4.69e+07. What is the difference between the highest and the lowest Grants(current US$) of Syrian Arab Republic?
Make the answer very short. 3.38e+08. 